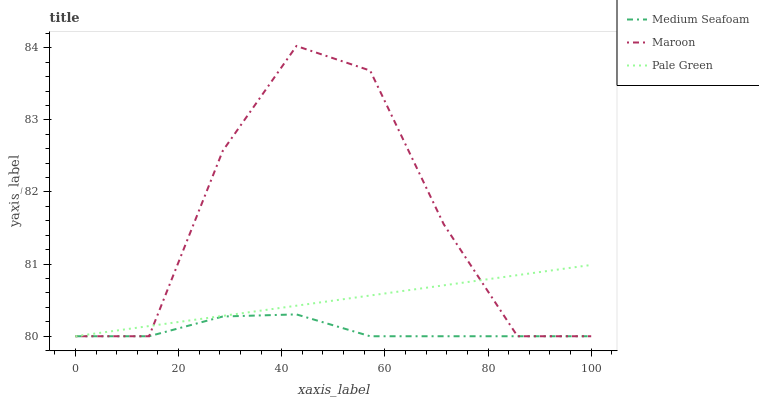Does Medium Seafoam have the minimum area under the curve?
Answer yes or no. Yes. Does Maroon have the maximum area under the curve?
Answer yes or no. Yes. Does Maroon have the minimum area under the curve?
Answer yes or no. No. Does Medium Seafoam have the maximum area under the curve?
Answer yes or no. No. Is Pale Green the smoothest?
Answer yes or no. Yes. Is Maroon the roughest?
Answer yes or no. Yes. Is Medium Seafoam the smoothest?
Answer yes or no. No. Is Medium Seafoam the roughest?
Answer yes or no. No. Does Pale Green have the lowest value?
Answer yes or no. Yes. Does Maroon have the highest value?
Answer yes or no. Yes. Does Medium Seafoam have the highest value?
Answer yes or no. No. Does Maroon intersect Pale Green?
Answer yes or no. Yes. Is Maroon less than Pale Green?
Answer yes or no. No. Is Maroon greater than Pale Green?
Answer yes or no. No. 